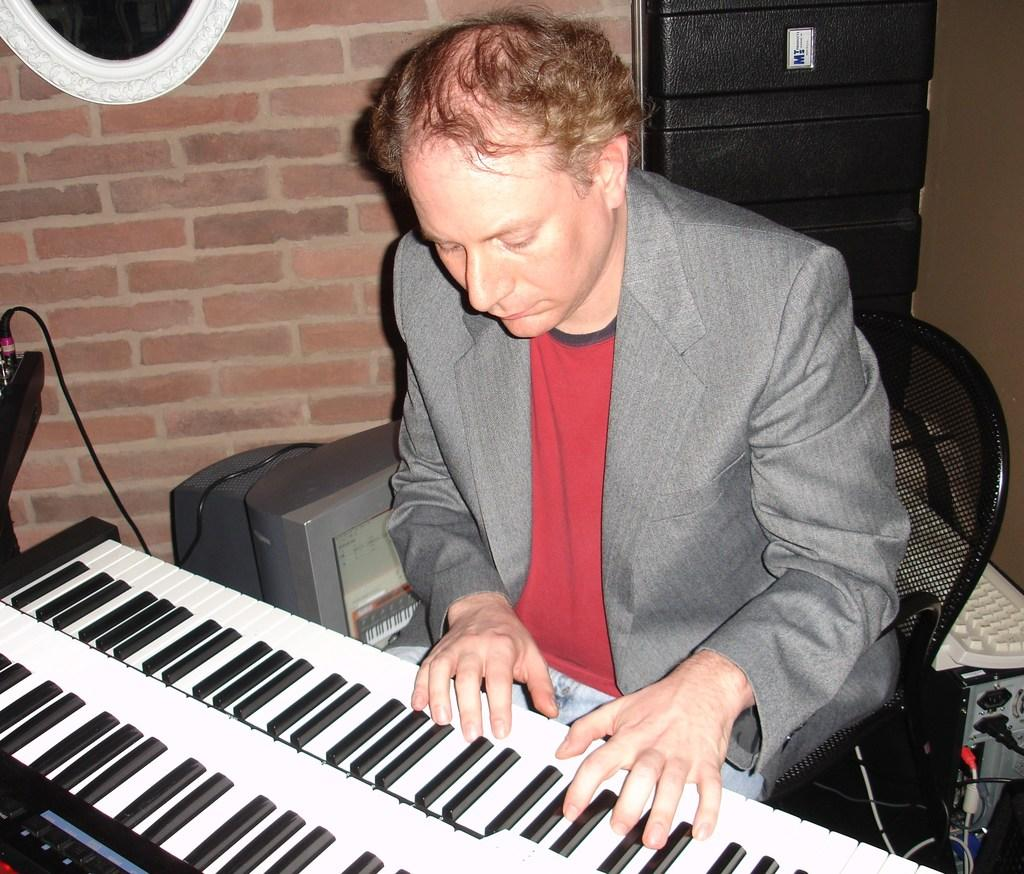What is the man in the image doing? The man is playing a musical instrument. What is the man sitting on in the image? The man is sitting on a chair. What can be seen on the desk or desktop in the image? The facts do not specify what is on the desk or desktop. What is visible in the background of the image? There is a wall in the background of the image. What is the current development and industry condition in the image? The image does not depict any development or industry, nor does it provide any information about their conditions. 